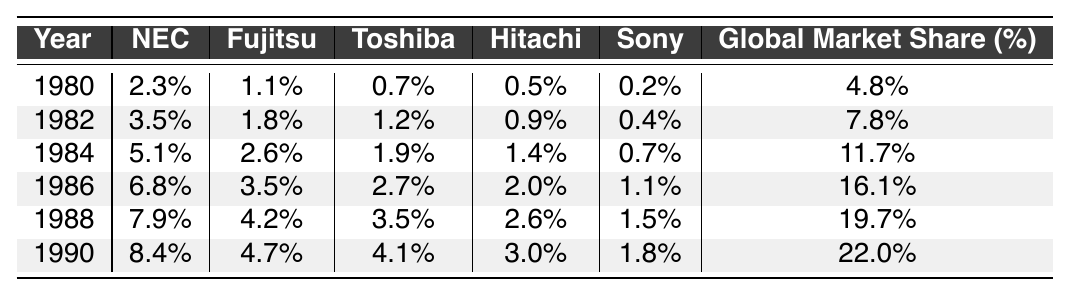What was the market share of NEC in 1986? In 1986, the table indicates that NEC's market share was 6.8%.
Answer: 6.8% Which company had the highest global market share in 1990? The table shows that in 1990, the highest global market share was 22.0%.
Answer: 22.0% What was the increase in Toshiba's market share from 1980 to 1990? Toshiba's market share in 1980 was 0.7%, and in 1990, it was 4.1%. The increase is calculated as 4.1% - 0.7% = 3.4%.
Answer: 3.4% Was Fujitsu's market share consistently increasing from 1980 to 1990? Reviewing the values in the table shows that Fujitsu's market shares were 1.1%, 1.8%, 2.6%, 3.5%, 4.2%, and 4.7% for the respective years, indicating a consistent increase.
Answer: Yes What is the average market share of all companies combined in 1984? To find the average market share in 1984, we add NEC (5.1%), Fujitsu (2.6%), Toshiba (1.9%), Hitachi (1.4%), and Sony (0.7%), which totals 11.7%. Since there are five companies, the average is 11.7%/5 = 2.34%.
Answer: 2.34% What company had the least market share in 1982? In 1982, among the listed companies, Sony had the least market share at 0.4%.
Answer: Sony By how much did the global market share increase from 1980 to 1990? The global market share in 1980 was 4.8% and in 1990 it was 22.0%. The increase is calculated as 22.0% - 4.8% = 17.2%.
Answer: 17.2% Did Hitachi's market share drop at any point between 1980 and 1990? The values for Hitachi in the table are 0.5%, 0.9%, 1.4%, 2.0%, 2.6%, and 3.0%, showing no drops and only increases over the years.
Answer: No What was Fujitsu's market share in 1988 compared to its market share in 1984? Fujitsu's market share in 1988 was 4.2%, and in 1984 it was 2.6%. The difference is 4.2% - 2.6% = 1.6%, indicating an increase.
Answer: 1.6% In which year did Sony first exceed 1% market share? Referring to the table, Sony's market share first exceeded 1% in 1986 when it reached 1.1%.
Answer: 1986 